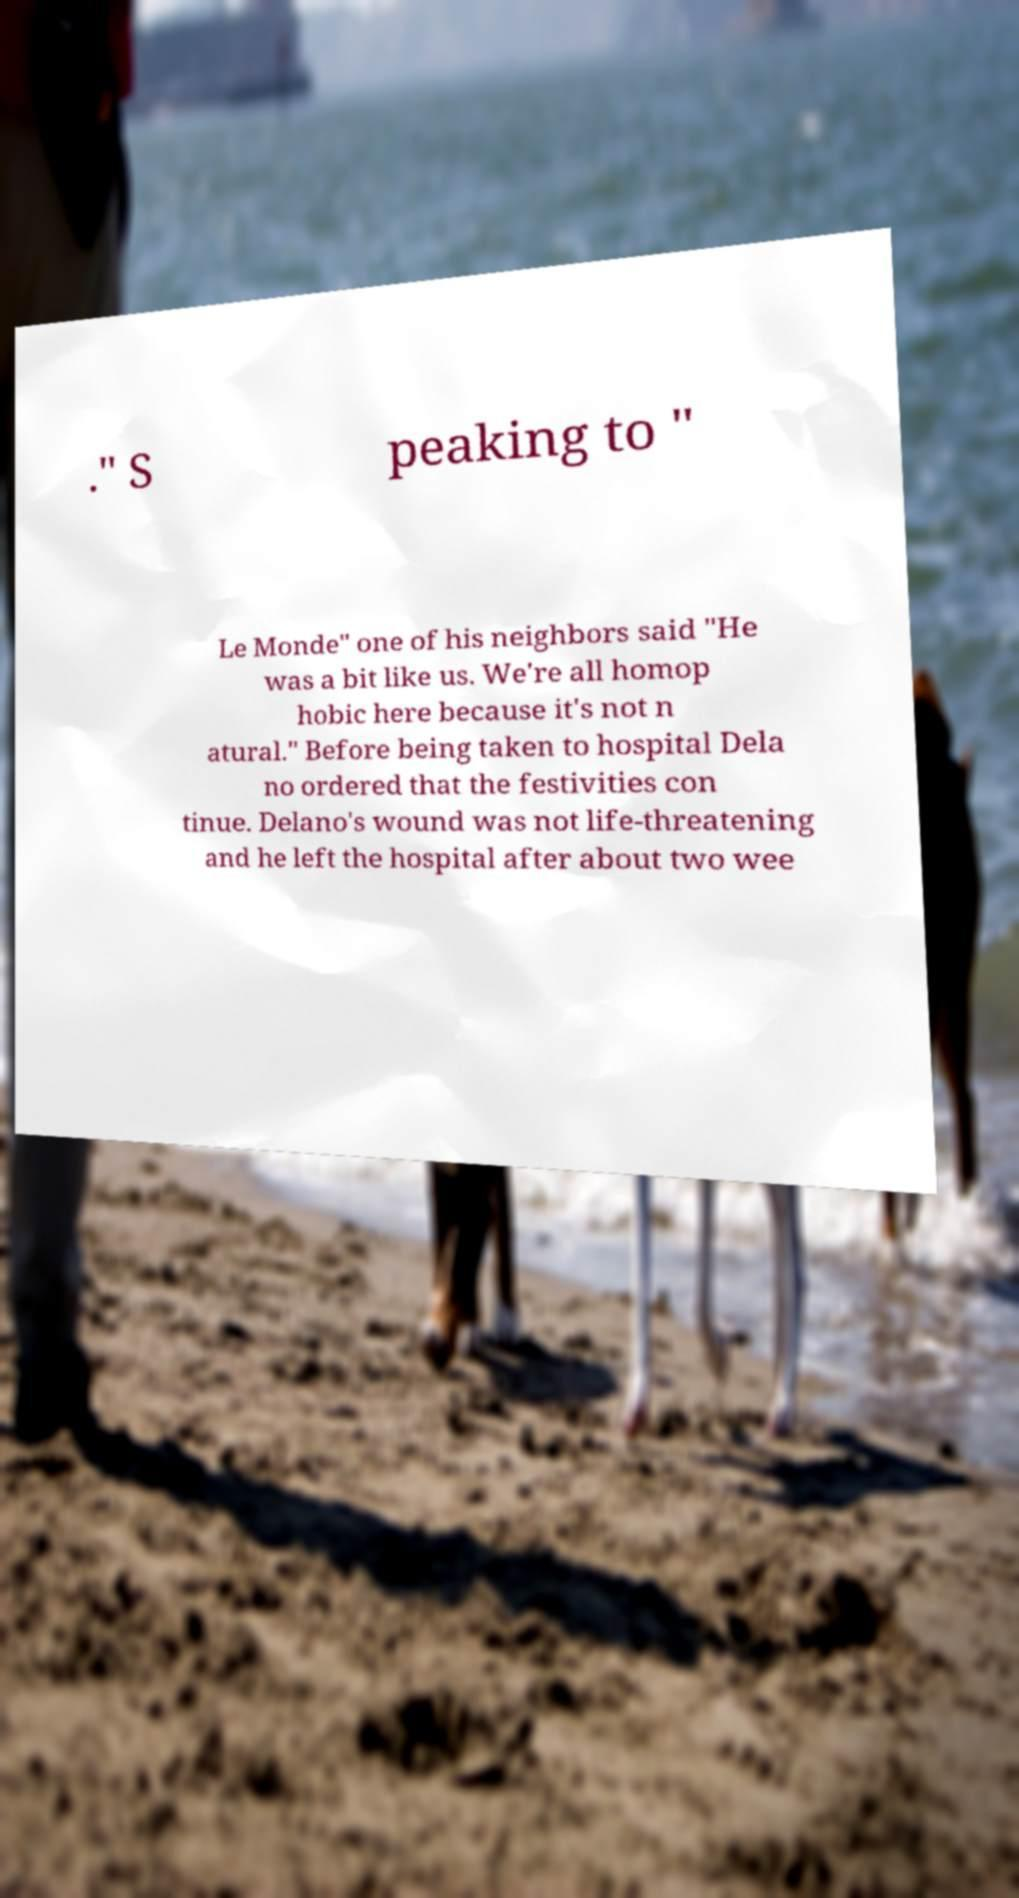Can you read and provide the text displayed in the image?This photo seems to have some interesting text. Can you extract and type it out for me? ." S peaking to " Le Monde" one of his neighbors said "He was a bit like us. We're all homop hobic here because it's not n atural." Before being taken to hospital Dela no ordered that the festivities con tinue. Delano's wound was not life-threatening and he left the hospital after about two wee 